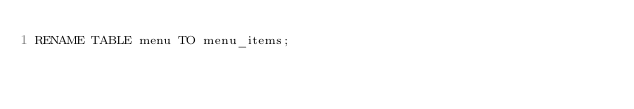Convert code to text. <code><loc_0><loc_0><loc_500><loc_500><_SQL_>RENAME TABLE menu TO menu_items;
</code> 